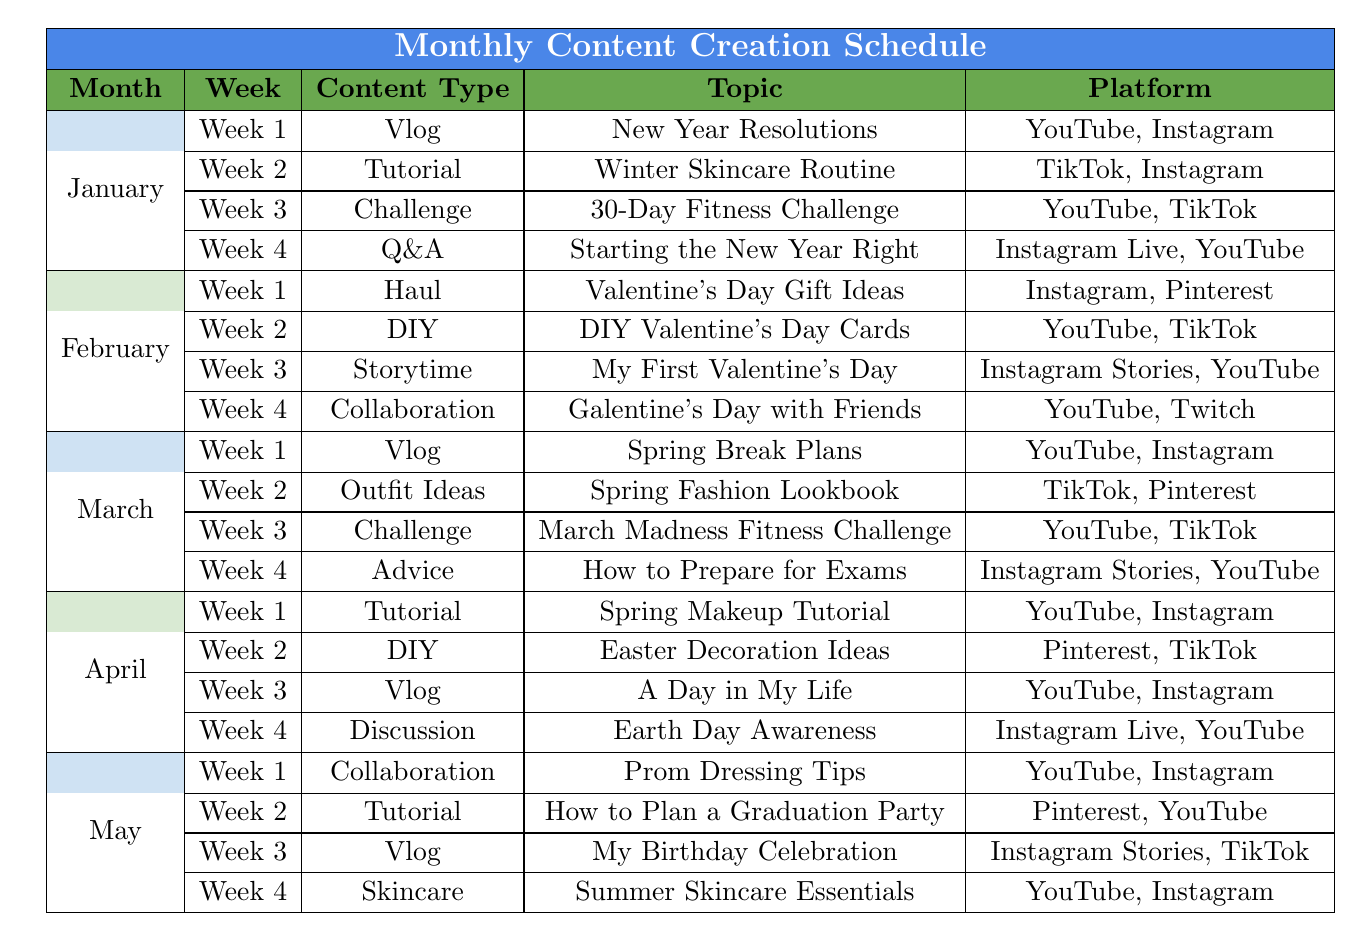What content type is created in the second week of February? In the table for February, the theme for Week 2 is categorized under content type "DIY" with the topic "DIY Valentine's Day Cards."
Answer: DIY Which month features a Spring Makeup Tutorial? Referring to the April section in the table, it is stated that Week 1 content type is "Tutorial" with the topic "Spring Makeup Tutorial."
Answer: April How many weeks in January focus on a vlog format? The data shows that in January, there are 4 weeks and only Week 1 contains a vlog ("New Year Resolutions"). Therefore, the count is 1.
Answer: 1 Is there a week in May dedicated to collaboration content type? Checking the May section, Week 1 specifies that the content type is "Collaboration" with the topic "Prom Dressing Tips." Hence, the answer is yes.
Answer: Yes Which content platforms are used for the 30-Day Fitness Challenge in March? The March section indicates that for Week 3, the content type is "Challenge" with the topic "30-Day Fitness Challenge." The platforms listed are "YouTube" and "TikTok."
Answer: YouTube, TikTok In which month do we find a discussion about Earth Day Awareness? Looking into the table, "Earth Day Awareness" is listed under the content type "Discussion" in Week 4 of April.
Answer: April How many weeks in total across all months contain a 'Vlog' theme? Analyzing the table, "Vlog" appears in January (Week 1), March (Week 1), and April (Week 3), leading to a total of 3 weeks.
Answer: 3 Which theme has the most diverse platform usage in January? In January, Week 1 uses "YouTube" and "Instagram," Week 2 uses "TikTok" and "Instagram," Week 3 uses "YouTube" and "TikTok," and Week 4 uses "Instagram Live" and "YouTube." All four weeks show some variety, but Week 2 has "TikTok" which is unique in comparison, hence giving it a unique status.
Answer: No clear winner What content type from February is not repeated in any other months? After comparing genres, "Storytime" specifically in Week 3 of February ("My First Valentine’s Day") does not appear in any other month.
Answer: Storytime How many DIY themes are there from January to April combined? The table shows that there are 2 occurrences of DIY: Week 2 in February and Week 2 in April. Adding them up yields a total of 2.
Answer: 2 